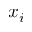Convert formula to latex. <formula><loc_0><loc_0><loc_500><loc_500>x _ { i }</formula> 